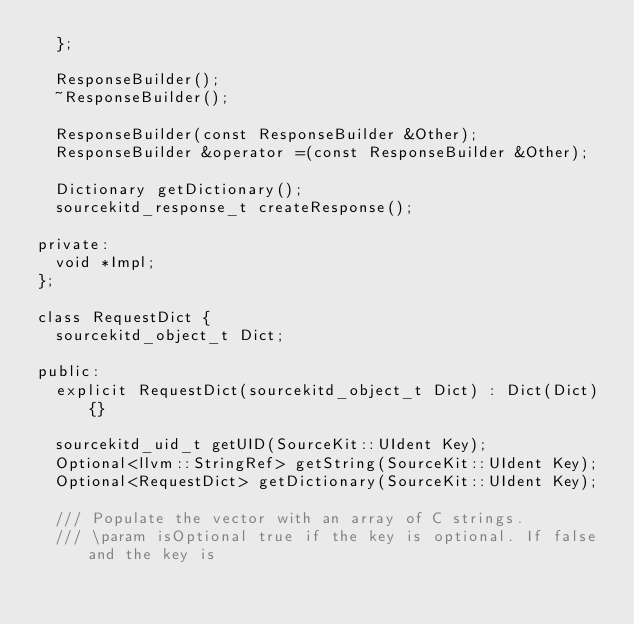Convert code to text. <code><loc_0><loc_0><loc_500><loc_500><_C_>  };

  ResponseBuilder();
  ~ResponseBuilder();

  ResponseBuilder(const ResponseBuilder &Other);
  ResponseBuilder &operator =(const ResponseBuilder &Other);

  Dictionary getDictionary();
  sourcekitd_response_t createResponse();

private:
  void *Impl;
};

class RequestDict {
  sourcekitd_object_t Dict;

public:
  explicit RequestDict(sourcekitd_object_t Dict) : Dict(Dict) {}

  sourcekitd_uid_t getUID(SourceKit::UIdent Key);
  Optional<llvm::StringRef> getString(SourceKit::UIdent Key);
  Optional<RequestDict> getDictionary(SourceKit::UIdent Key);

  /// Populate the vector with an array of C strings.
  /// \param isOptional true if the key is optional. If false and the key is</code> 